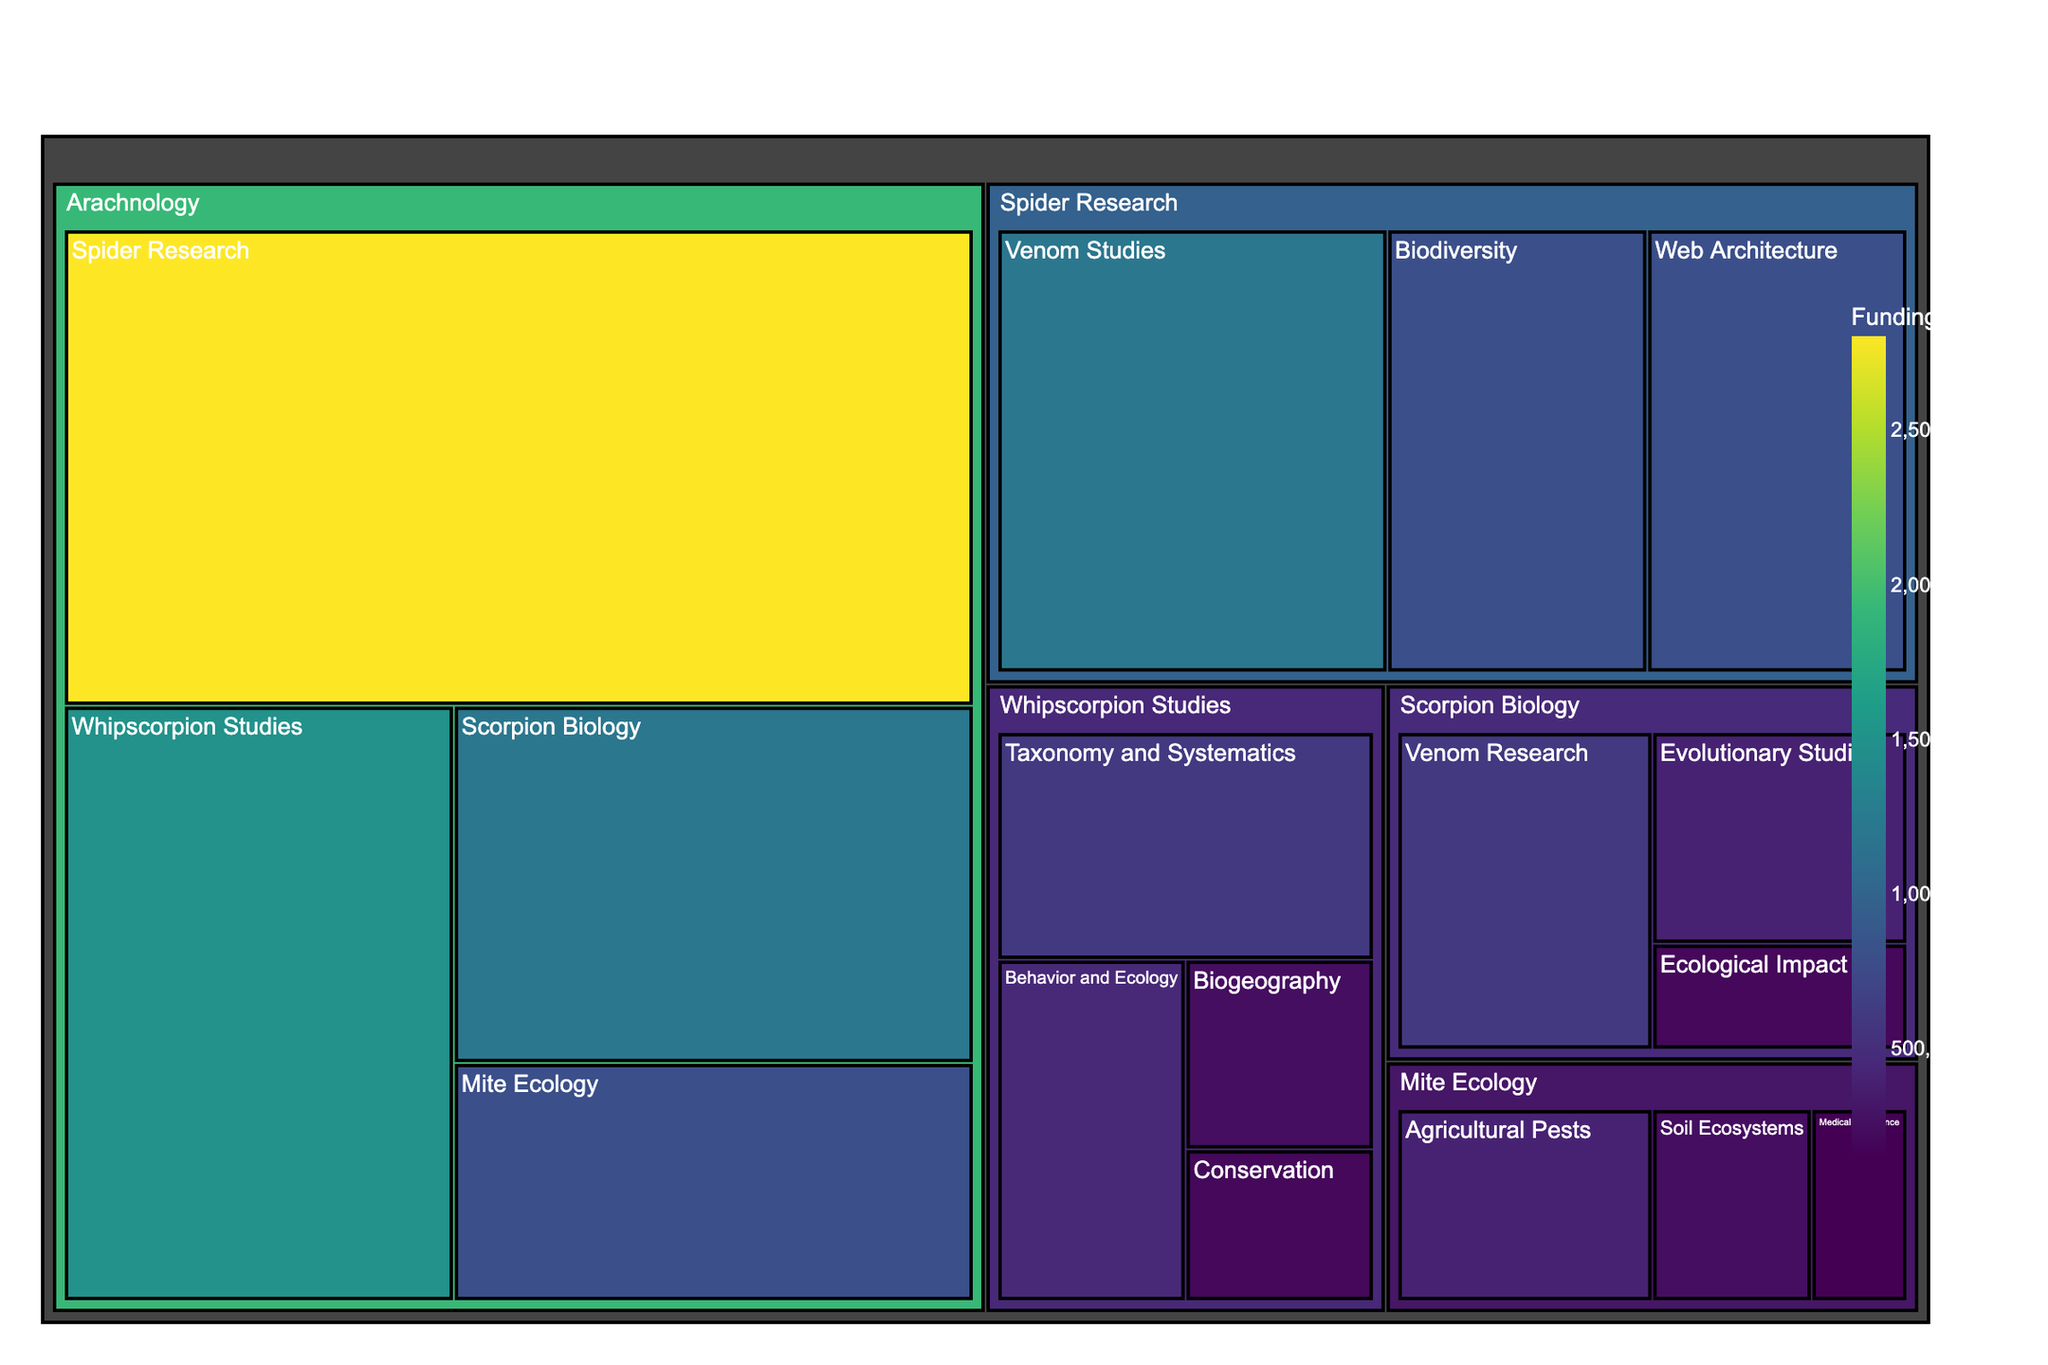What is the highest funded subcategory? The subcategory with the highest funding can be identified by locating the largest box in the treemap. The largest box corresponds to Spider Research with $2,800,000 in funding.
Answer: Spider Research What is the total funding allocated to whipscorpion-related projects? To find the total funding for whipscorpion-related projects, sum the fund amounts for all subcategories under Whipscorpion Studies: $600,000 + $450,000 + $250,000 + $200,000 = $1,500,000.
Answer: $1,500,000 Which research subcategory under Mite Ecology has the least funding? By examining the different subcategories under Mite Ecology, the smallest box which represents Medical Importance has the least funding with $150,000.
Answer: Medical Importance How does the funding for Behavior and Ecology studies compare to Conservation in whipscorpions? Compare the sizes of the boxes for Behavior and Ecology and Conservation. Behavior and Ecology has $450,000 whereas Conservation has $200,000, indicating Behavior and Ecology is funded more.
Answer: Behavior and Ecology is funded more What is the combined funding for Venom-related research across all arachnology categories? Add the funding amounts for Venom Studies in Spider Research and Venom Research in Scorpion Biology: $1,200,000 + $600,000 = $1,800,000.
Answer: $1,800,000 Which has more funding: Web Architecture research in spiders or Scorpion Biology as a whole? Web Architecture in Spider Research is funded $800,000. The total funding for Scorpion Biology is the sum of all its subcategories: $600,000 + $400,000 + $200,000 = $1,200,000. Therefore, Scorpion Biology as a whole has more funding.
Answer: Scorpion Biology What percentage of the total arachnology funding is dedicated to Mite Ecology? First, calculate total arachnology funding: $1,500,000 (Whipscorpion Studies) + $2,800,000 (Spider Research) + $1,200,000 (Scorpion Biology) + $800,000 (Mite Ecology) = $6,300,000. Then, find the percentage: ($800,000 / $6,300,000) * 100% ≈ 12.7%.
Answer: ~12.7% Which category receives the least amount of funding overall? Compare the total funding allocated to each main category. Mite Ecology has the least with $800,000.
Answer: Mite Ecology 